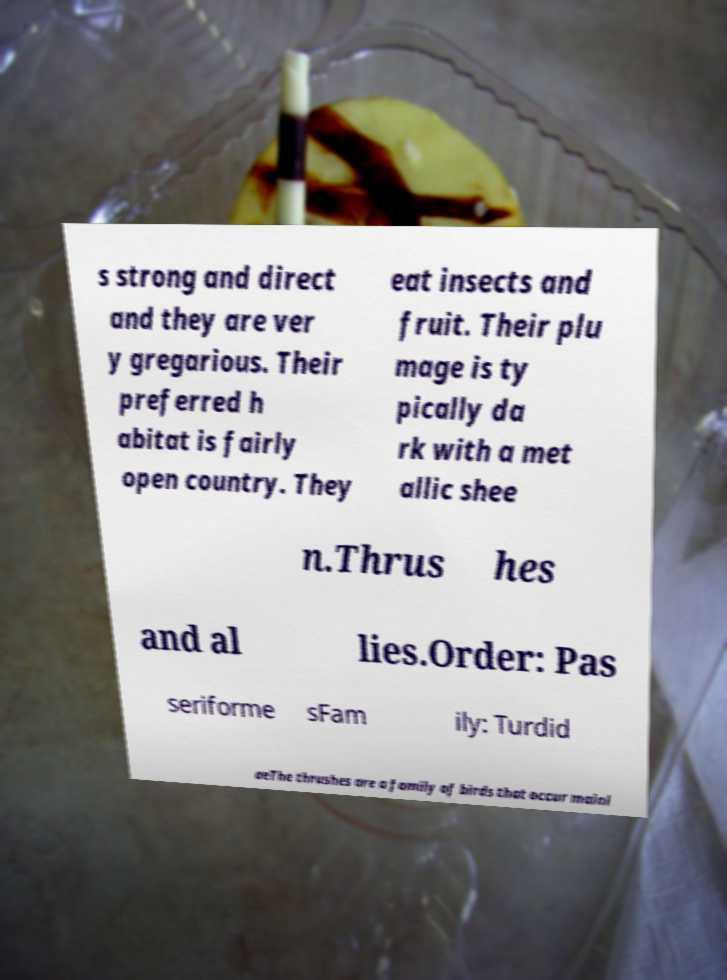For documentation purposes, I need the text within this image transcribed. Could you provide that? s strong and direct and they are ver y gregarious. Their preferred h abitat is fairly open country. They eat insects and fruit. Their plu mage is ty pically da rk with a met allic shee n.Thrus hes and al lies.Order: Pas seriforme sFam ily: Turdid aeThe thrushes are a family of birds that occur mainl 